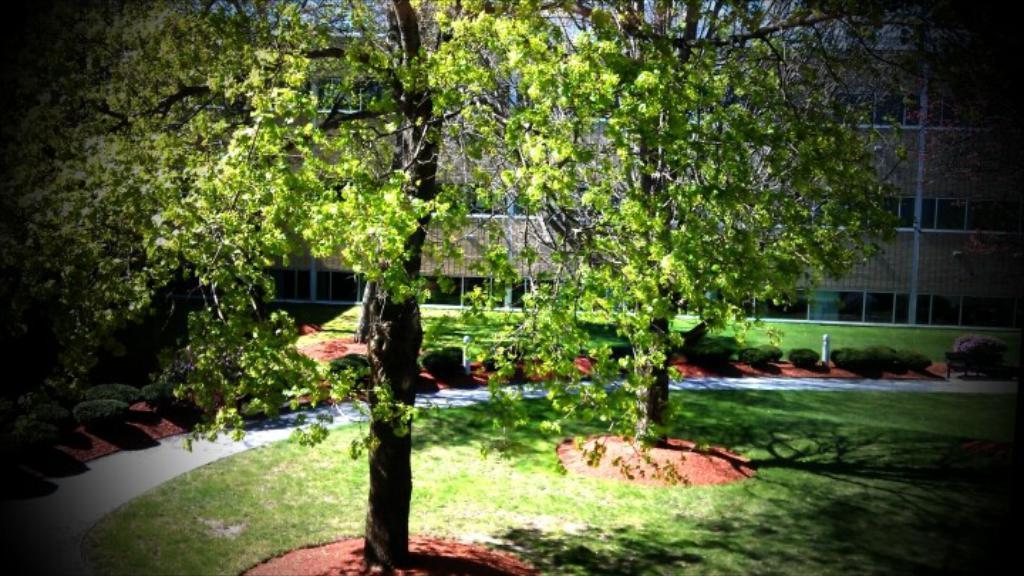How would you summarize this image in a sentence or two? In the picture I can see two trees which are placed on a greenery ground and there are few trees and a building in the background. 